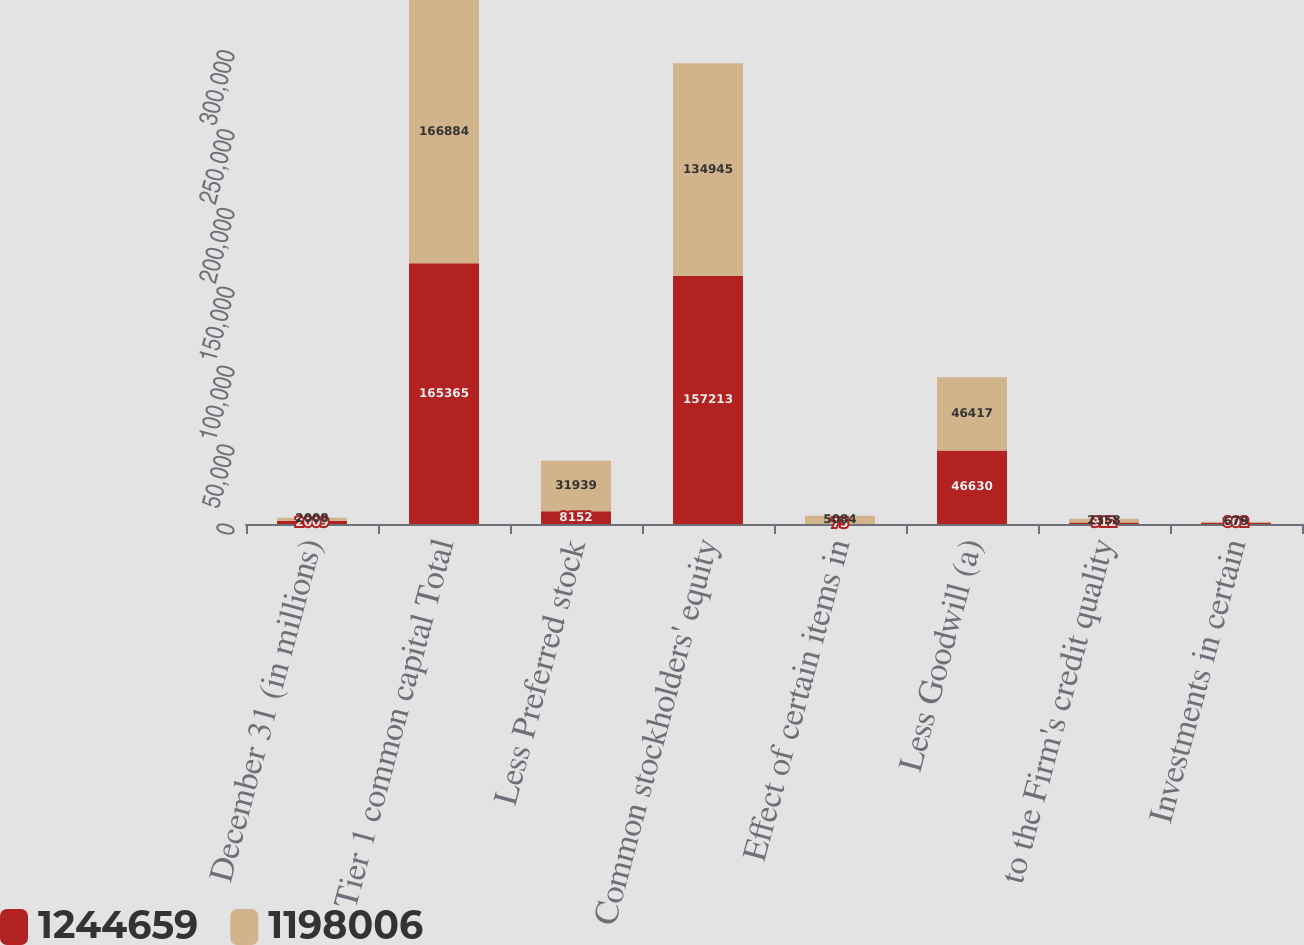Convert chart to OTSL. <chart><loc_0><loc_0><loc_500><loc_500><stacked_bar_chart><ecel><fcel>December 31 (in millions)<fcel>Tier 1 common capital Total<fcel>Less Preferred stock<fcel>Common stockholders' equity<fcel>Effect of certain items in<fcel>Less Goodwill (a)<fcel>to the Firm's credit quality<fcel>Investments in certain<nl><fcel>1.24466e+06<fcel>2009<fcel>165365<fcel>8152<fcel>157213<fcel>75<fcel>46630<fcel>912<fcel>802<nl><fcel>1.19801e+06<fcel>2008<fcel>166884<fcel>31939<fcel>134945<fcel>5084<fcel>46417<fcel>2358<fcel>679<nl></chart> 